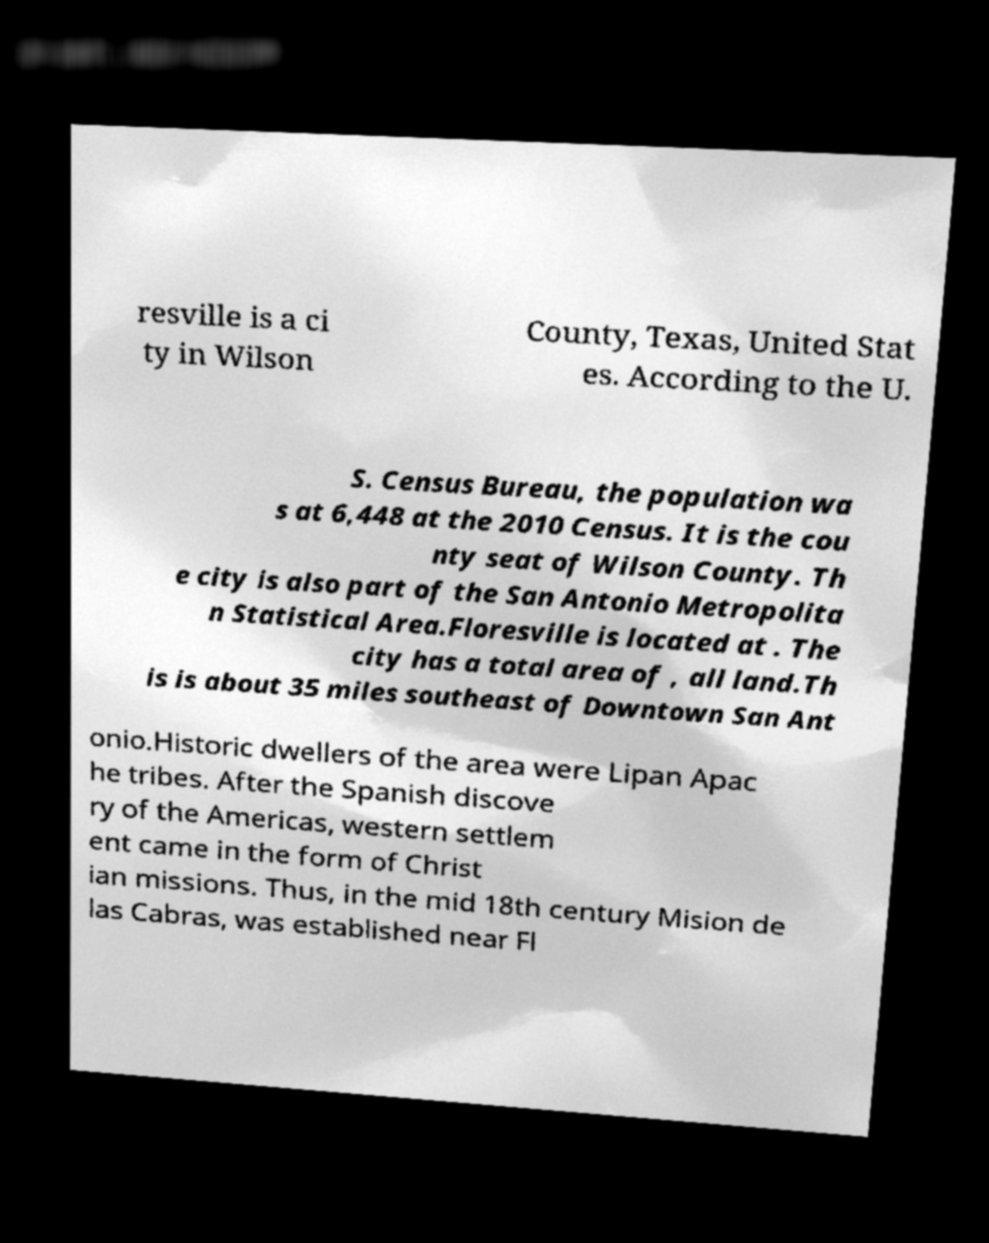There's text embedded in this image that I need extracted. Can you transcribe it verbatim? resville is a ci ty in Wilson County, Texas, United Stat es. According to the U. S. Census Bureau, the population wa s at 6,448 at the 2010 Census. It is the cou nty seat of Wilson County. Th e city is also part of the San Antonio Metropolita n Statistical Area.Floresville is located at . The city has a total area of , all land.Th is is about 35 miles southeast of Downtown San Ant onio.Historic dwellers of the area were Lipan Apac he tribes. After the Spanish discove ry of the Americas, western settlem ent came in the form of Christ ian missions. Thus, in the mid 18th century Mision de las Cabras, was established near Fl 